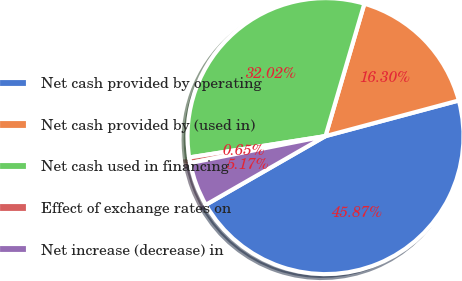Convert chart to OTSL. <chart><loc_0><loc_0><loc_500><loc_500><pie_chart><fcel>Net cash provided by operating<fcel>Net cash provided by (used in)<fcel>Net cash used in financing<fcel>Effect of exchange rates on<fcel>Net increase (decrease) in<nl><fcel>45.87%<fcel>16.3%<fcel>32.02%<fcel>0.65%<fcel>5.17%<nl></chart> 